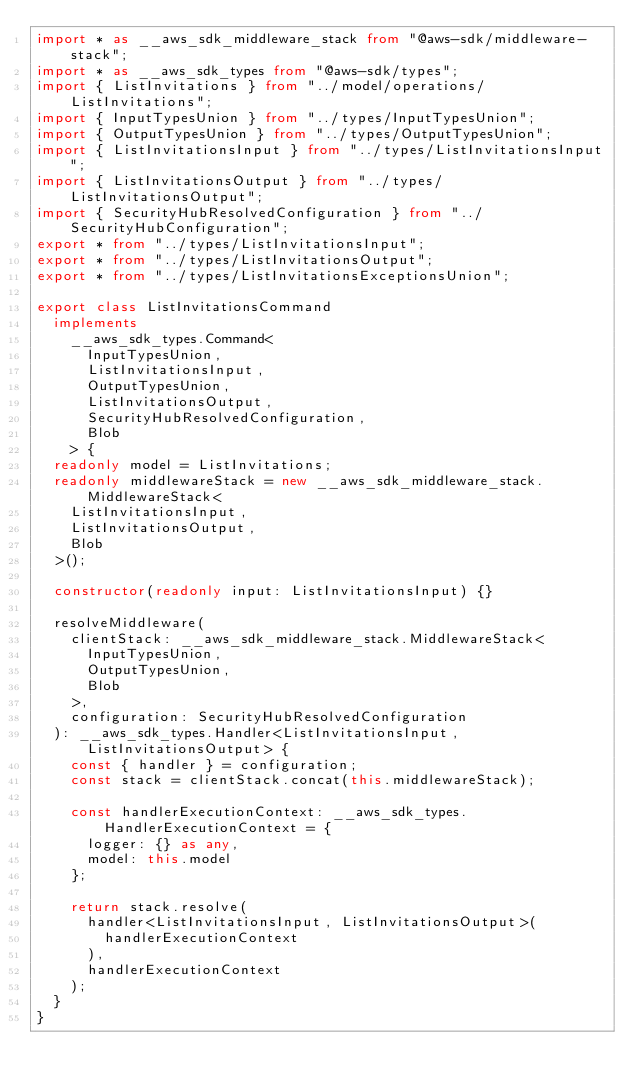Convert code to text. <code><loc_0><loc_0><loc_500><loc_500><_TypeScript_>import * as __aws_sdk_middleware_stack from "@aws-sdk/middleware-stack";
import * as __aws_sdk_types from "@aws-sdk/types";
import { ListInvitations } from "../model/operations/ListInvitations";
import { InputTypesUnion } from "../types/InputTypesUnion";
import { OutputTypesUnion } from "../types/OutputTypesUnion";
import { ListInvitationsInput } from "../types/ListInvitationsInput";
import { ListInvitationsOutput } from "../types/ListInvitationsOutput";
import { SecurityHubResolvedConfiguration } from "../SecurityHubConfiguration";
export * from "../types/ListInvitationsInput";
export * from "../types/ListInvitationsOutput";
export * from "../types/ListInvitationsExceptionsUnion";

export class ListInvitationsCommand
  implements
    __aws_sdk_types.Command<
      InputTypesUnion,
      ListInvitationsInput,
      OutputTypesUnion,
      ListInvitationsOutput,
      SecurityHubResolvedConfiguration,
      Blob
    > {
  readonly model = ListInvitations;
  readonly middlewareStack = new __aws_sdk_middleware_stack.MiddlewareStack<
    ListInvitationsInput,
    ListInvitationsOutput,
    Blob
  >();

  constructor(readonly input: ListInvitationsInput) {}

  resolveMiddleware(
    clientStack: __aws_sdk_middleware_stack.MiddlewareStack<
      InputTypesUnion,
      OutputTypesUnion,
      Blob
    >,
    configuration: SecurityHubResolvedConfiguration
  ): __aws_sdk_types.Handler<ListInvitationsInput, ListInvitationsOutput> {
    const { handler } = configuration;
    const stack = clientStack.concat(this.middlewareStack);

    const handlerExecutionContext: __aws_sdk_types.HandlerExecutionContext = {
      logger: {} as any,
      model: this.model
    };

    return stack.resolve(
      handler<ListInvitationsInput, ListInvitationsOutput>(
        handlerExecutionContext
      ),
      handlerExecutionContext
    );
  }
}
</code> 